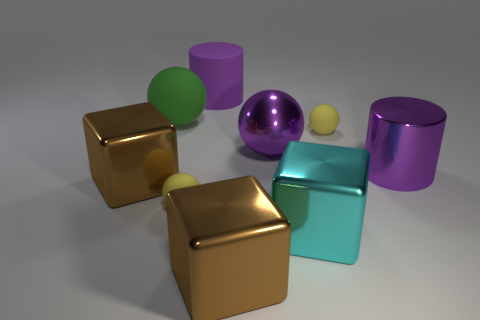Is there a big brown metallic block to the right of the cylinder that is behind the purple thing that is to the right of the cyan cube?
Make the answer very short. Yes. The big cyan thing that is the same material as the purple sphere is what shape?
Ensure brevity in your answer.  Cube. What is the shape of the large purple rubber object?
Offer a very short reply. Cylinder. Is the shape of the large brown metallic thing that is to the left of the large green ball the same as  the cyan metallic thing?
Offer a terse response. Yes. Is the number of cylinders behind the green ball greater than the number of large matte spheres behind the large purple rubber thing?
Give a very brief answer. Yes. How many other things are the same size as the shiny cylinder?
Your answer should be compact. 6. There is a purple matte thing; is it the same shape as the green object that is behind the cyan block?
Give a very brief answer. No. What number of metal things are either purple spheres or big brown blocks?
Your response must be concise. 3. Is there a large metal sphere that has the same color as the rubber cylinder?
Offer a very short reply. Yes. Are any cyan rubber things visible?
Offer a terse response. No. 